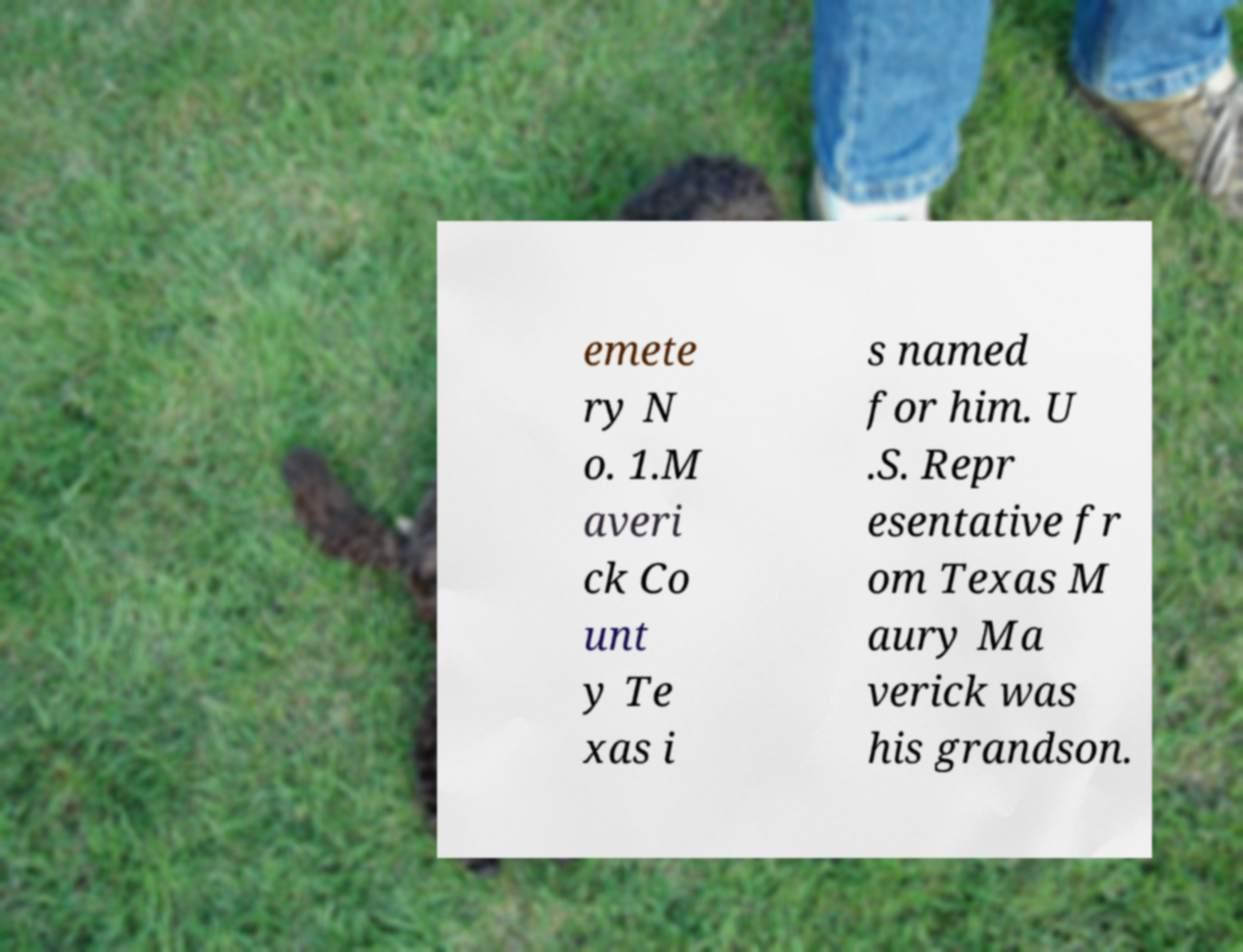Could you extract and type out the text from this image? emete ry N o. 1.M averi ck Co unt y Te xas i s named for him. U .S. Repr esentative fr om Texas M aury Ma verick was his grandson. 